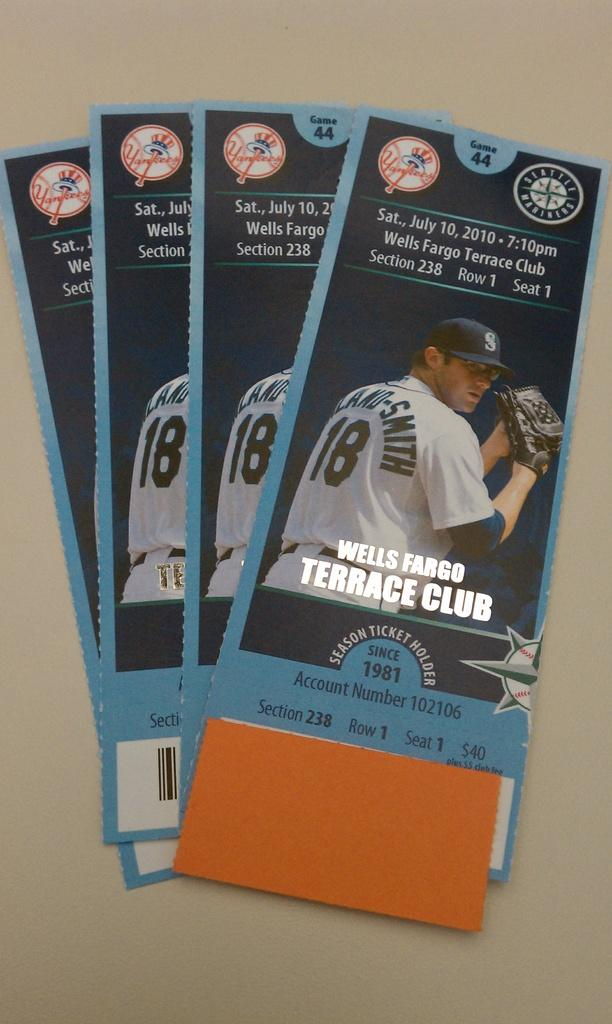<image>
Provide a brief description of the given image. Baseball tickets are on a table for the Wells Fargo Terrace Club. 